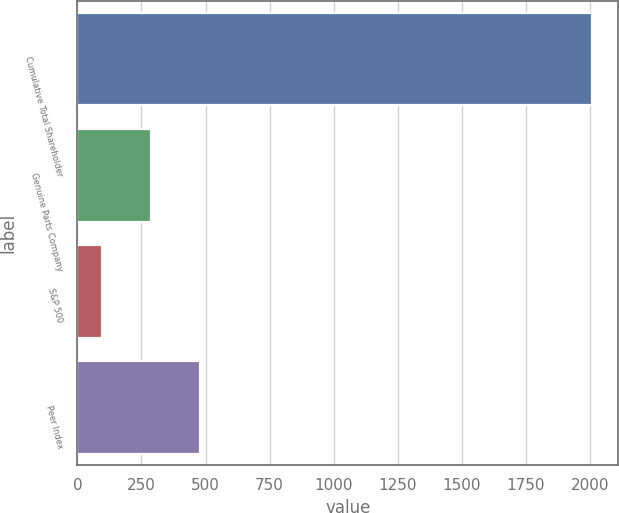Convert chart. <chart><loc_0><loc_0><loc_500><loc_500><bar_chart><fcel>Cumulative Total Shareholder<fcel>Genuine Parts Company<fcel>S&P 500<fcel>Peer Index<nl><fcel>2009<fcel>288.48<fcel>97.31<fcel>479.65<nl></chart> 